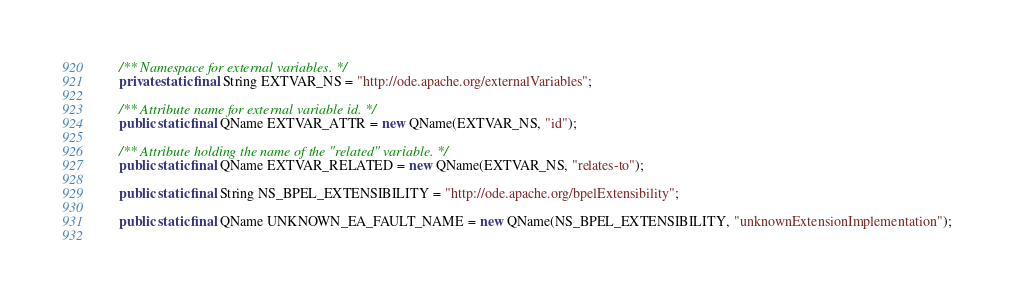Convert code to text. <code><loc_0><loc_0><loc_500><loc_500><_Java_>    /** Namespace for external variables. */
    private static final String EXTVAR_NS = "http://ode.apache.org/externalVariables";
    
    /** Attribute name for external variable id. */
    public static final QName EXTVAR_ATTR = new QName(EXTVAR_NS, "id");
    
    /** Attribute holding the name of the "related" variable. */
	public static final QName EXTVAR_RELATED = new QName(EXTVAR_NS, "relates-to");

    public static final String NS_BPEL_EXTENSIBILITY = "http://ode.apache.org/bpelExtensibility";
    	
    public static final QName UNKNOWN_EA_FAULT_NAME = new QName(NS_BPEL_EXTENSIBILITY, "unknownExtensionImplementation");
    	</code> 